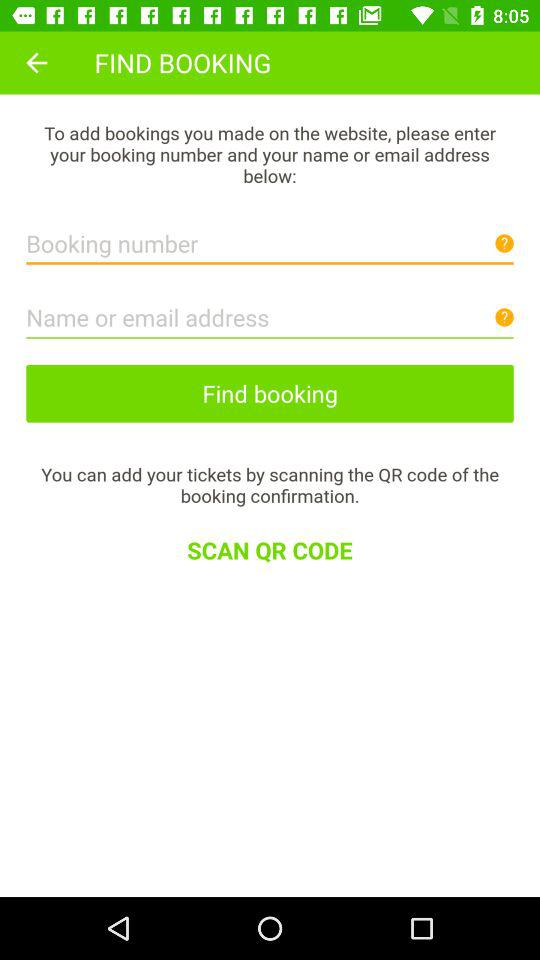How many text inputs are there for contact information?
Answer the question using a single word or phrase. 2 